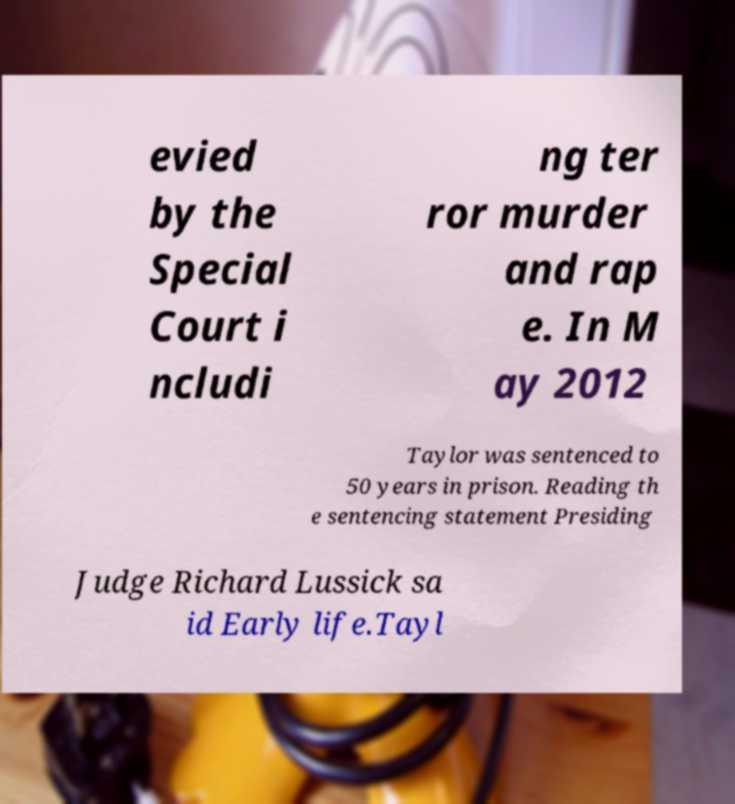There's text embedded in this image that I need extracted. Can you transcribe it verbatim? evied by the Special Court i ncludi ng ter ror murder and rap e. In M ay 2012 Taylor was sentenced to 50 years in prison. Reading th e sentencing statement Presiding Judge Richard Lussick sa id Early life.Tayl 